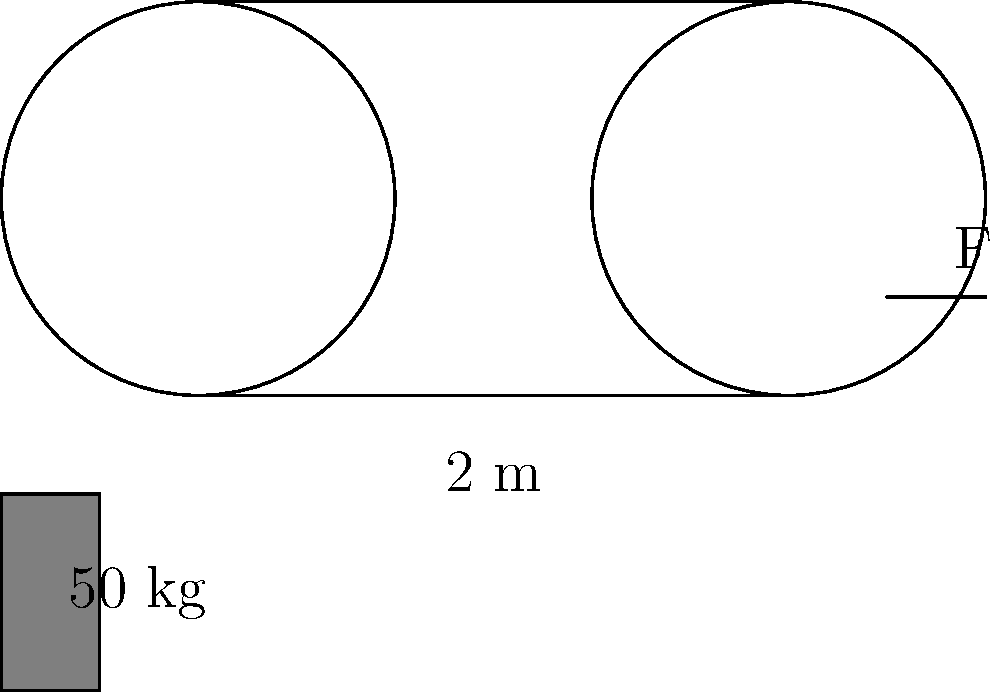In a simple pulley system used by early pioneers to lift heavy loads, a 50 kg weight is suspended from one end of a rope that passes over two fixed pulleys, as shown in the diagram. If the pulleys are frictionless and the rope is massless, what force F (in Newtons) is required to hold the weight in equilibrium? (Use g = 9.8 m/s²) To solve this problem, let's follow these steps:

1. Understand the system:
   - We have a 50 kg weight suspended on one side.
   - The rope passes over two fixed pulleys.
   - The pulleys are frictionless, and the rope is massless.

2. Calculate the weight of the 50 kg mass:
   $W = mg = 50 \text{ kg} \times 9.8 \text{ m/s²} = 490 \text{ N}$

3. Analyze the force distribution:
   - In a frictionless pulley system, the tension in the rope is constant throughout.
   - The weight is distributed equally between the two sections of rope supporting it.

4. Calculate the force F:
   - Since the weight is distributed over two sections of rope, the force F will be half of the total weight.
   $F = \frac{W}{2} = \frac{490 \text{ N}}{2} = 245 \text{ N}$

5. Check the equilibrium:
   - The upward force (2F) equals the downward force (W), confirming equilibrium.
   $2F = 2 \times 245 \text{ N} = 490 \text{ N} = W$

Therefore, a force of 245 N is required to hold the weight in equilibrium.
Answer: 245 N 